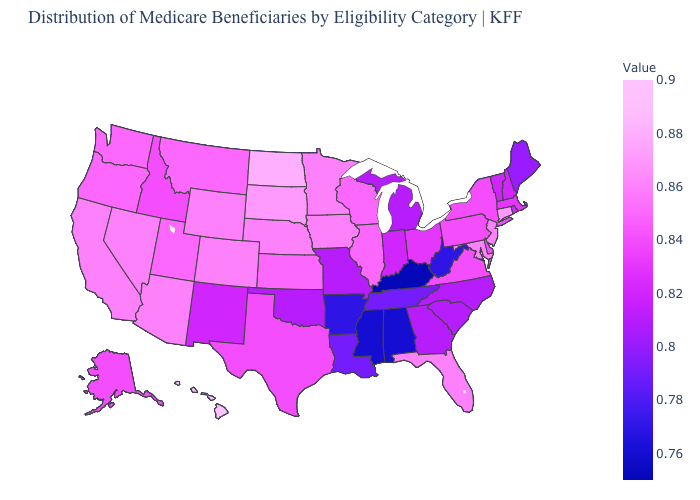Does the map have missing data?
Be succinct. No. Does Illinois have the lowest value in the MidWest?
Give a very brief answer. No. Is the legend a continuous bar?
Short answer required. Yes. Does the map have missing data?
Short answer required. No. Which states have the lowest value in the West?
Keep it brief. New Mexico. Does the map have missing data?
Quick response, please. No. 